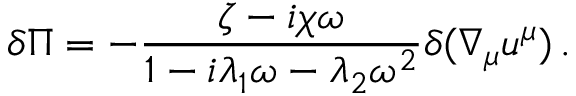<formula> <loc_0><loc_0><loc_500><loc_500>\delta \Pi = - \frac { \zeta - i \chi \omega } { 1 - i \lambda _ { 1 } \omega - \lambda _ { 2 } \omega ^ { 2 } } \delta ( \nabla _ { \mu } u ^ { \mu } ) \, .</formula> 